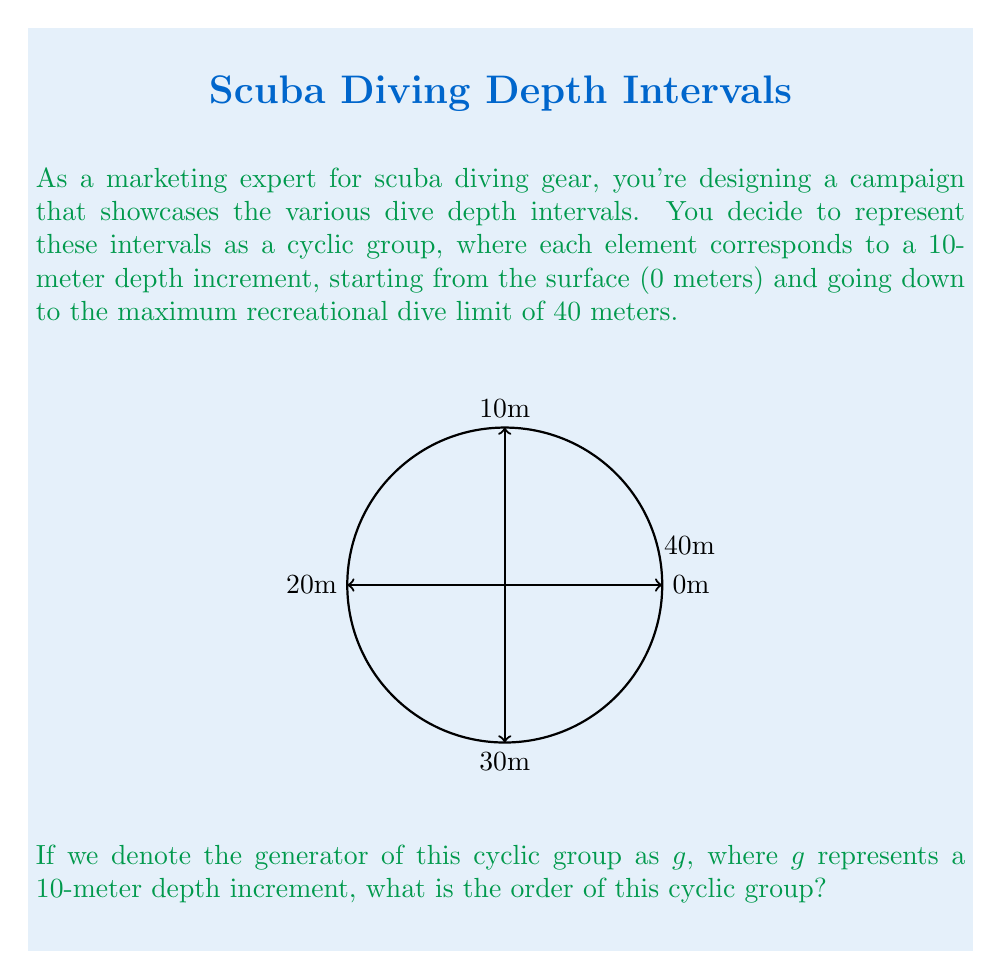Can you answer this question? To find the order of this cyclic group, we need to determine the smallest positive integer $n$ such that $g^n = e$, where $e$ is the identity element of the group.

Let's analyze the elements of the group:

1) $e$ (or $g^0$): 0 meters (surface)
2) $g$: 10 meters
3) $g^2$: 20 meters
4) $g^3$: 30 meters
5) $g^4$: 40 meters
6) $g^5$: This would be 50 meters, but it cycles back to 0 meters (surface)

We can see that $g^5 = e$, and this is the smallest positive integer that satisfies this equation.

Therefore, the order of the cyclic group is 5.

This makes sense in the context of our dive depth intervals:
$$\{0\text{m}, 10\text{m}, 20\text{m}, 30\text{m}, 40\text{m}\}$$

These 5 elements form a cyclic group under the operation of "adding 10 meters and taking the result modulo 50 meters".
Answer: 5 